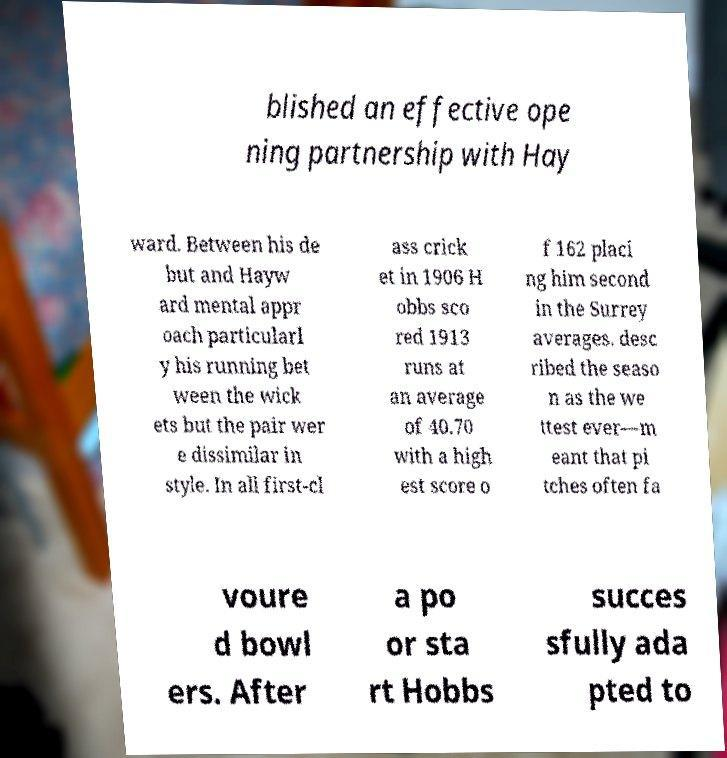Please read and relay the text visible in this image. What does it say? blished an effective ope ning partnership with Hay ward. Between his de but and Hayw ard mental appr oach particularl y his running bet ween the wick ets but the pair wer e dissimilar in style. In all first-cl ass crick et in 1906 H obbs sco red 1913 runs at an average of 40.70 with a high est score o f 162 placi ng him second in the Surrey averages. desc ribed the seaso n as the we ttest ever—m eant that pi tches often fa voure d bowl ers. After a po or sta rt Hobbs succes sfully ada pted to 